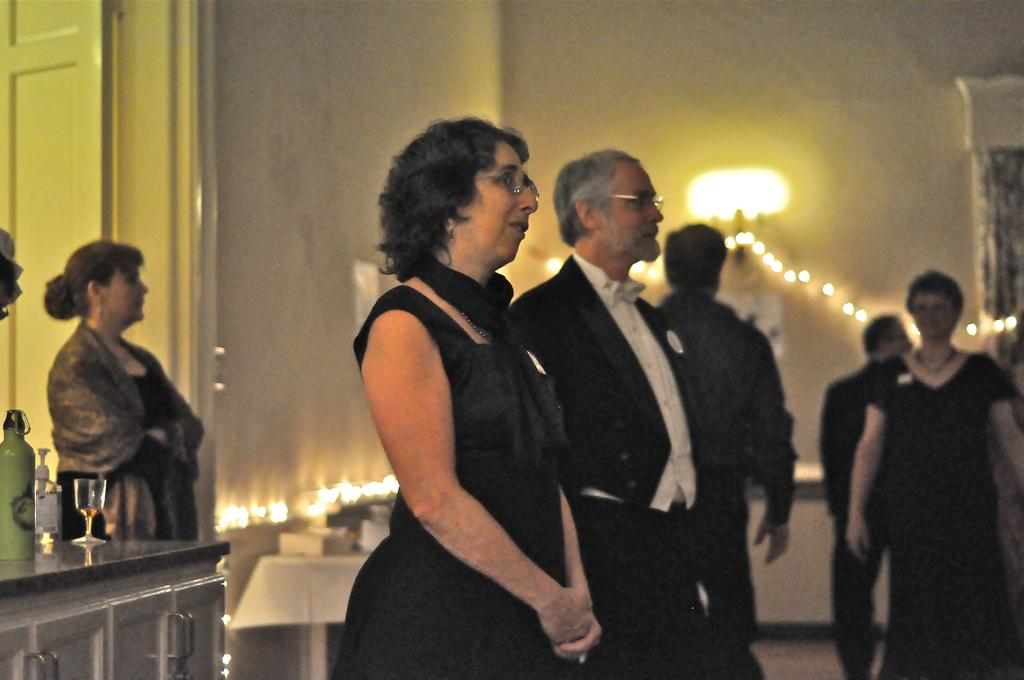How many people are present in the room? There are many people standing in the room. What is located in the room besides the people? There is a table in the room. What items can be found on the table? There is a bottle and a glass on the table. What type of lighting is present in the room? There are lights on the wall. What type of powder is being used by the man in the image? There is no man or powder present in the image. 